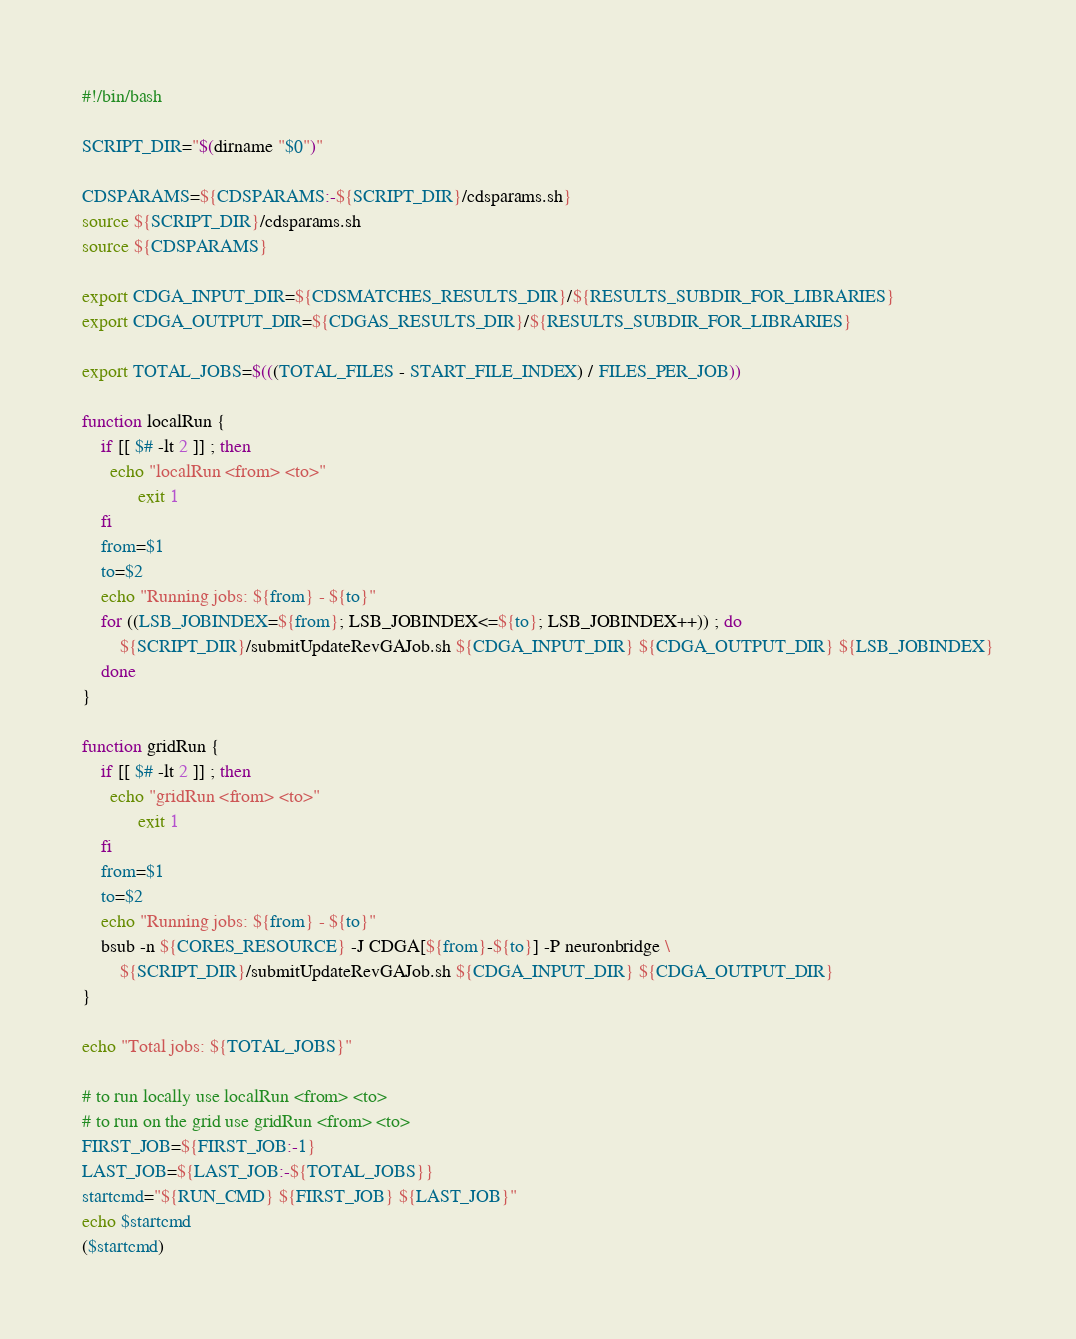Convert code to text. <code><loc_0><loc_0><loc_500><loc_500><_Bash_>#!/bin/bash

SCRIPT_DIR="$(dirname "$0")"

CDSPARAMS=${CDSPARAMS:-${SCRIPT_DIR}/cdsparams.sh}
source ${SCRIPT_DIR}/cdsparams.sh
source ${CDSPARAMS}

export CDGA_INPUT_DIR=${CDSMATCHES_RESULTS_DIR}/${RESULTS_SUBDIR_FOR_LIBRARIES}
export CDGA_OUTPUT_DIR=${CDGAS_RESULTS_DIR}/${RESULTS_SUBDIR_FOR_LIBRARIES}

export TOTAL_JOBS=$(((TOTAL_FILES - START_FILE_INDEX) / FILES_PER_JOB))

function localRun {
    if [[ $# -lt 2 ]] ; then
      echo "localRun <from> <to>"
            exit 1
    fi
    from=$1
    to=$2
    echo "Running jobs: ${from} - ${to}"
    for ((LSB_JOBINDEX=${from}; LSB_JOBINDEX<=${to}; LSB_JOBINDEX++)) ; do
        ${SCRIPT_DIR}/submitUpdateRevGAJob.sh ${CDGA_INPUT_DIR} ${CDGA_OUTPUT_DIR} ${LSB_JOBINDEX}
    done
}

function gridRun {
    if [[ $# -lt 2 ]] ; then
      echo "gridRun <from> <to>"
            exit 1
    fi
    from=$1
    to=$2
    echo "Running jobs: ${from} - ${to}"
    bsub -n ${CORES_RESOURCE} -J CDGA[${from}-${to}] -P neuronbridge \
        ${SCRIPT_DIR}/submitUpdateRevGAJob.sh ${CDGA_INPUT_DIR} ${CDGA_OUTPUT_DIR}
}

echo "Total jobs: ${TOTAL_JOBS}"

# to run locally use localRun <from> <to>
# to run on the grid use gridRun <from> <to>
FIRST_JOB=${FIRST_JOB:-1}
LAST_JOB=${LAST_JOB:-${TOTAL_JOBS}}
startcmd="${RUN_CMD} ${FIRST_JOB} ${LAST_JOB}"
echo $startcmd
($startcmd)
</code> 